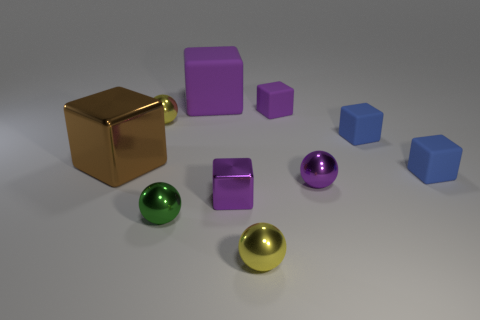Are the green ball and the tiny purple block in front of the brown cube made of the same material?
Give a very brief answer. Yes. How many purple objects are the same shape as the large brown metallic thing?
Your response must be concise. 3. There is a small sphere that is the same color as the small shiny block; what is its material?
Offer a very short reply. Metal. What number of tiny purple metallic spheres are there?
Provide a short and direct response. 1. Is the shape of the large brown shiny thing the same as the blue object in front of the large shiny object?
Provide a succinct answer. Yes. How many things are brown shiny balls or purple objects behind the tiny purple rubber object?
Provide a succinct answer. 1. What is the material of the tiny purple thing that is the same shape as the tiny green metal thing?
Make the answer very short. Metal. There is a yellow object that is to the right of the tiny green metallic sphere; does it have the same shape as the big matte object?
Give a very brief answer. No. Are there any other things that have the same size as the purple shiny ball?
Offer a terse response. Yes. Is the number of things that are behind the big brown metal block less than the number of large purple rubber objects that are in front of the purple ball?
Your answer should be very brief. No. 